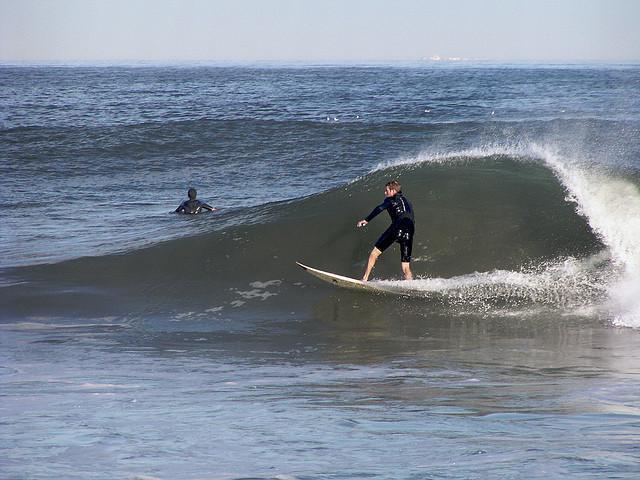How many people are laying on their board?
Give a very brief answer. 1. 